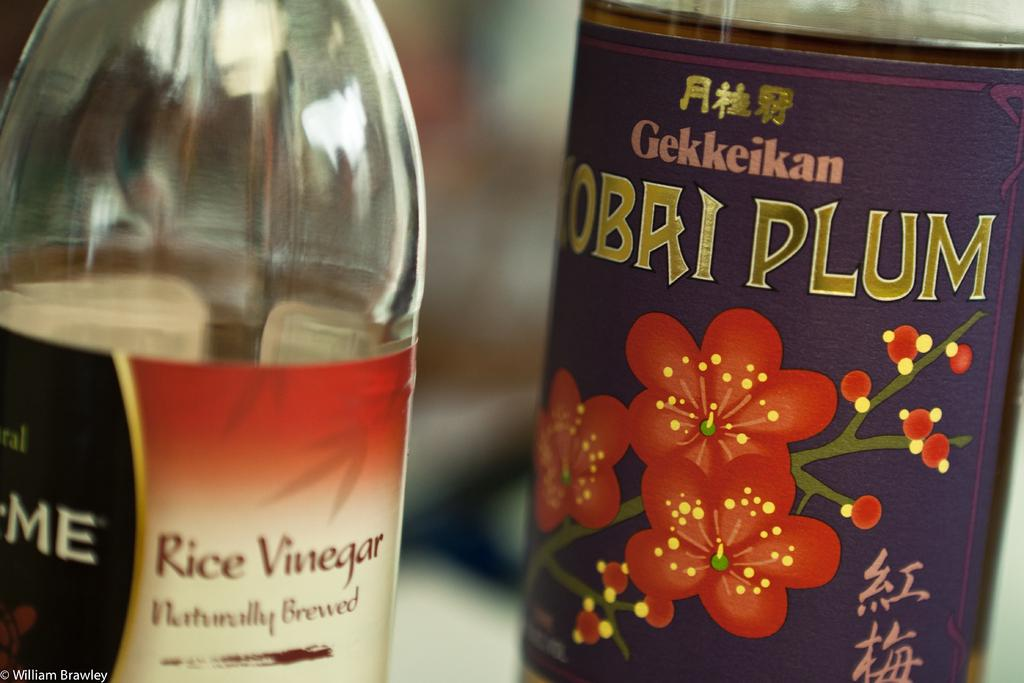How many bottles are visible in the image? There are two bottles in the image. Are there any snails crawling on the bottles in the image? There is no mention of snails in the image, so we cannot determine if there are any snails present. What type of cracker is shown next to the bottles in the image? There is no mention of a cracker in the image, so we cannot determine if there is a cracker present. 